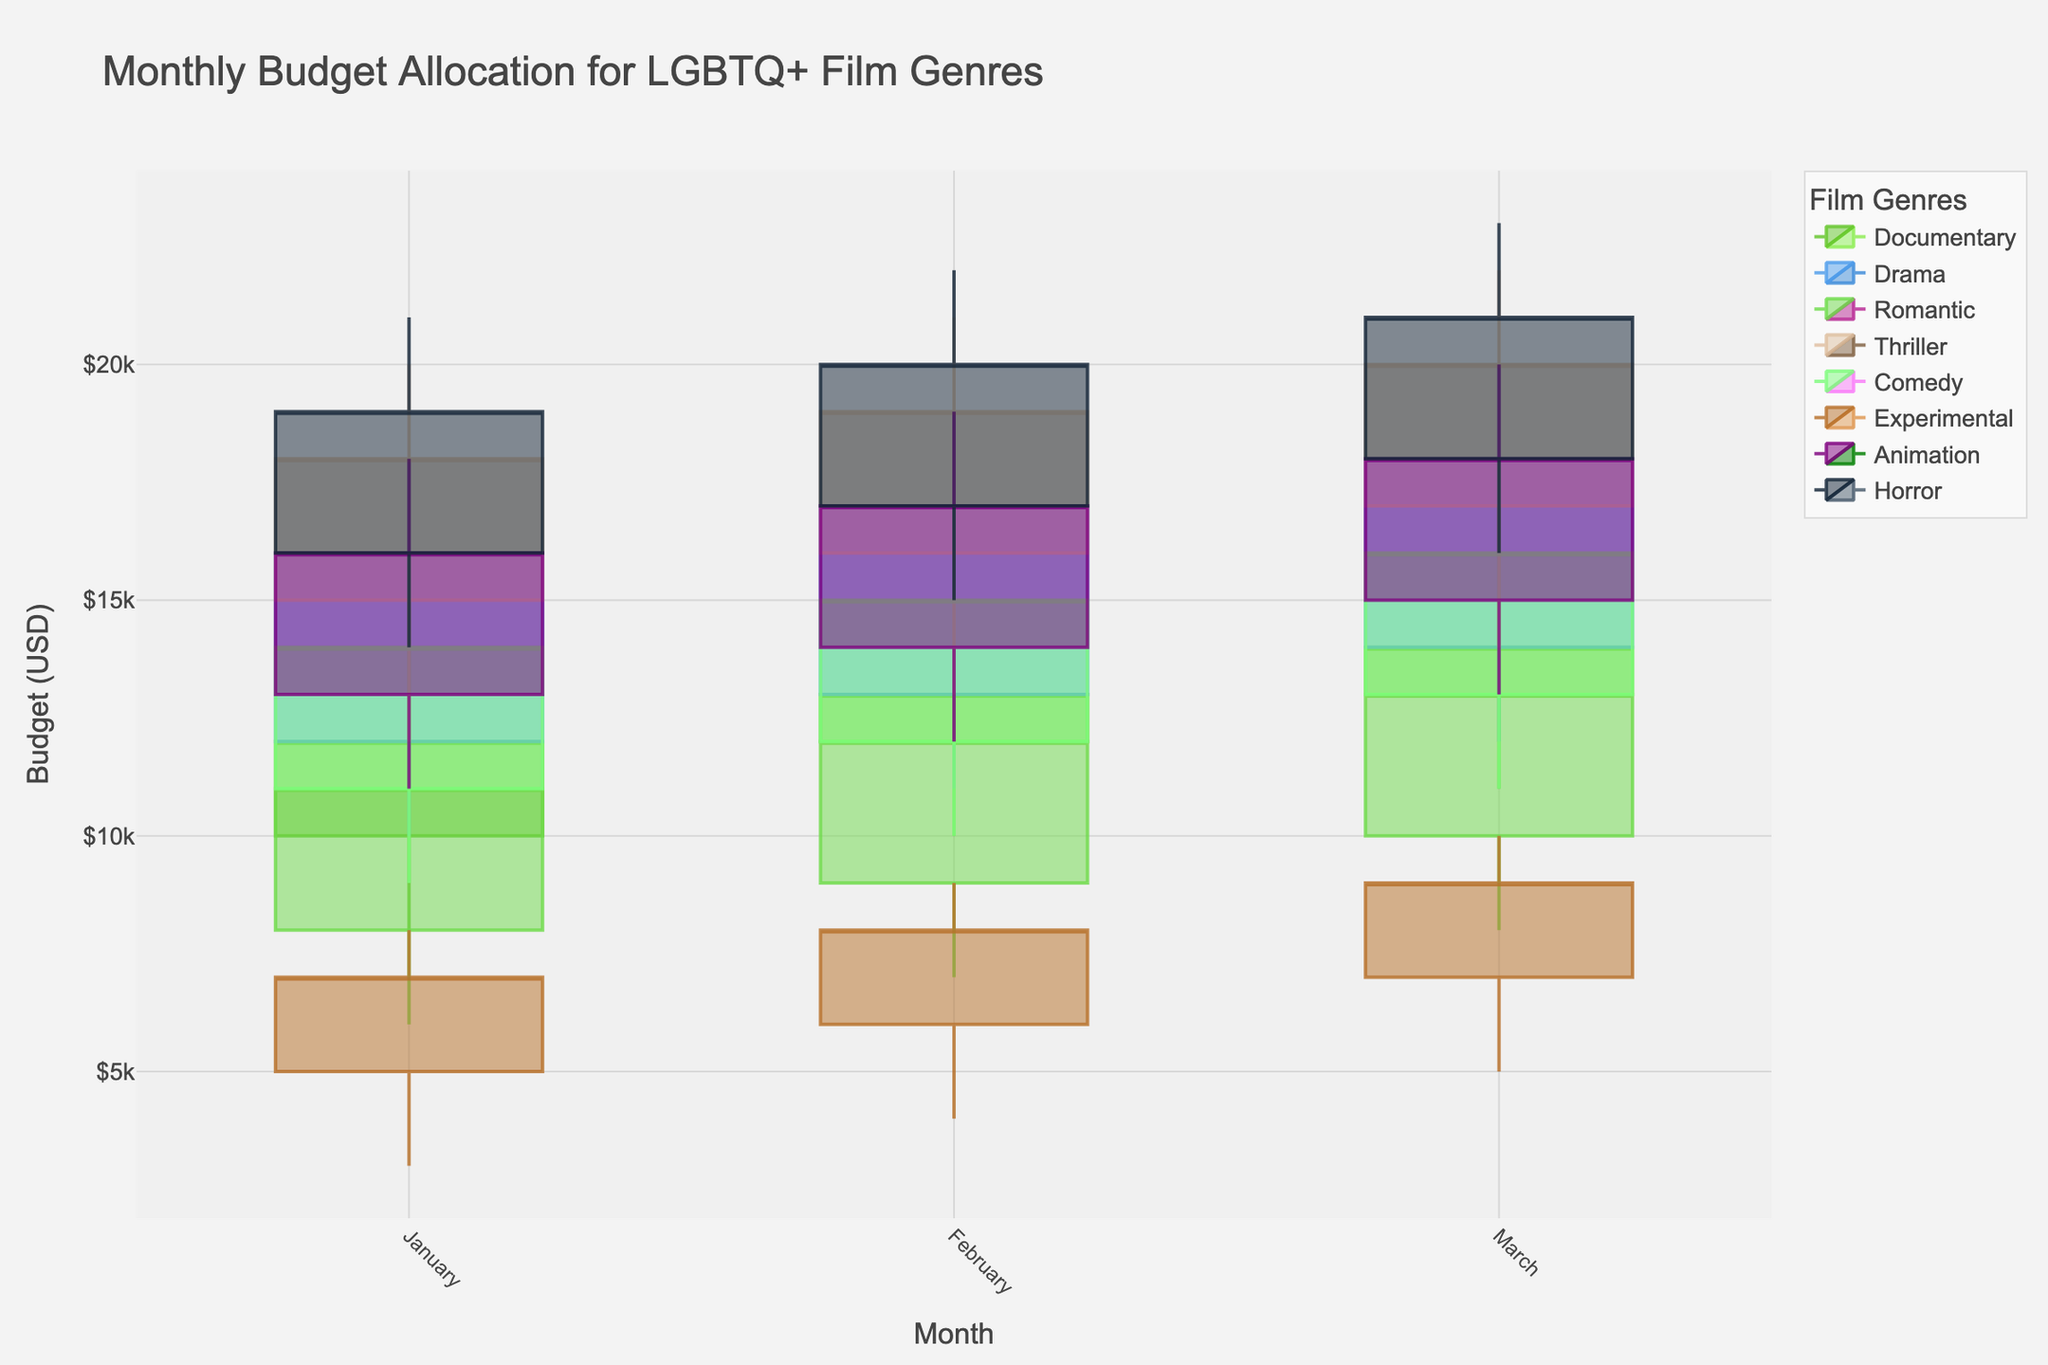Which genre had the highest budget allocation in March? In March, the genre with the highest budget allocation can be identified by looking for the genre with the highest "High" value in March. Thriller, with a high value of $22,000, has the highest budget allocation in March.
Answer: Thriller How did the budget for Documentaries change from January to March? To determine the change in the budget for Documentaries from January to March, compare the "Close" values. In January, the close value was $12,000, and in March, it was $14,000. Hence, the budget increased by $2,000.
Answer: Increased by $2,000 Which genre's budget had the largest range in January? To identify the genre with the largest budget range in January, find the difference between the "High" and "Low" values for each genre in January. Thriller had the largest range, with a high of $20,000 and a low of $12,000, resulting in a range of $8,000.
Answer: Thriller What is the average closing budget for Drama over the three months? Calculate the average closing budget for Drama by summing the "Close" values for January, February, and March, then dividing by 3. The sum is ($16,000 + $17,000 + $18,000) = $51,000, and the average is $51,000/3 = $17,000.
Answer: $17,000 Between Romantic and Comedy genres, which had a higher budget variation in February? Determine the budget variation for both genres in February by comparing their "High" and "Low" values. For Romantic, the variation is $14,000 - $7,000 = $7,000. For Comedy, it is $17,000 - $10,000 = $7,000. Both had equal variations.
Answer: Both equal Did the budget for Experimental films increase or decrease from January to March? Compare the "Close" values of Experimental films from January ($7,000) to March ($9,000). The budget increased by $2,000.
Answer: Increased Which month had the highest budget allocation for Horror films? Look for the month with the highest "High" value for Horror films. March has the highest value at $23,000.
Answer: March Did the budget allocation pattern for Animation films show a consistent increase, decrease, or fluctuate across the three months? Check the "Close" values for Animation films over January ($16,000), February ($17,000), and March ($18,000). The values show a consistent increase.
Answer: Consistent increase What's the budget range for Comedy films in March? For Comedy films in March, find the difference between the "High" and "Low" values. The high is $18,000, and the low is $11,000, resulting in a range of $7,000.
Answer: $7,000 Which genre had the least variation in budget allocation in February? To find the genre with the least variation in February, check the difference between "High" and "Low" values. Experimental shows the least with a variation of $9,000 - $4,000 = $5,000.
Answer: Experimental 